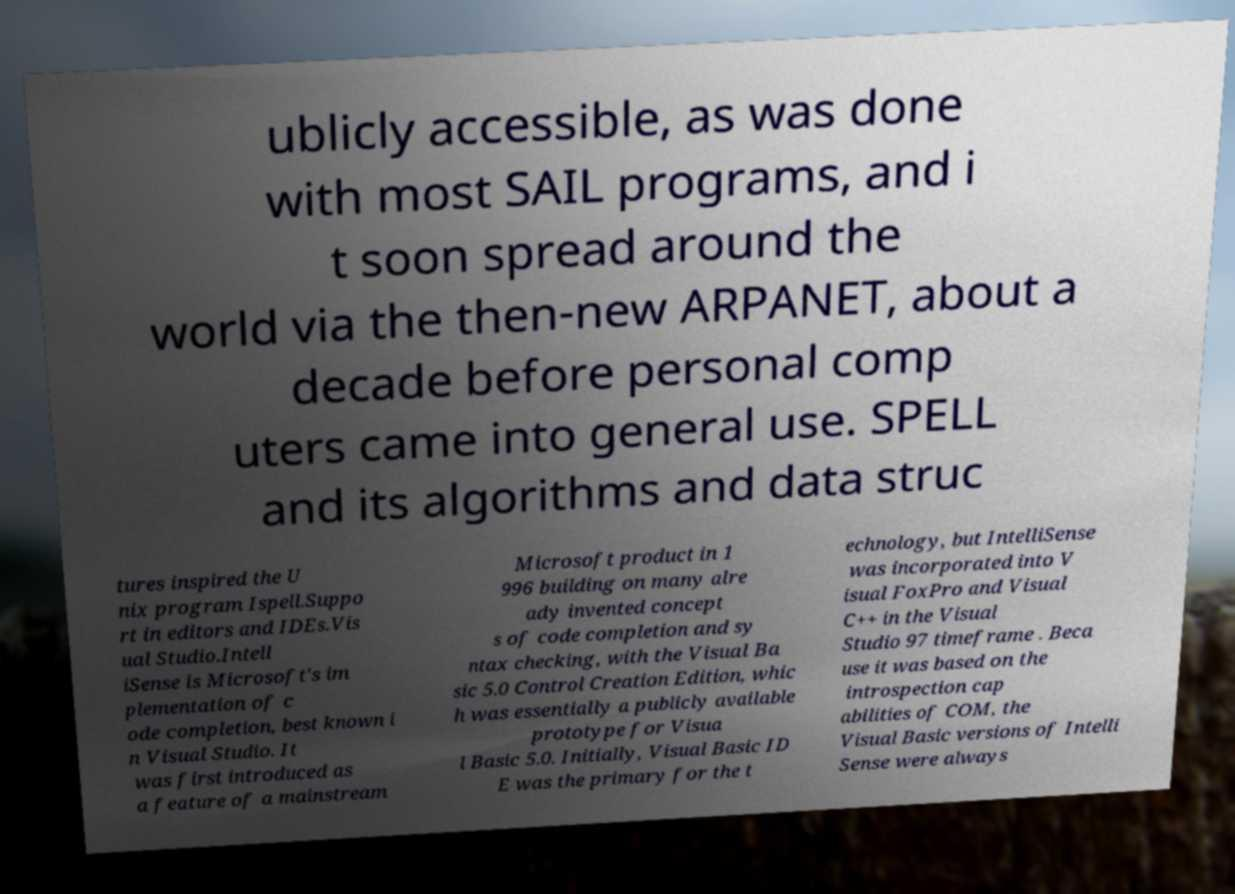There's text embedded in this image that I need extracted. Can you transcribe it verbatim? ublicly accessible, as was done with most SAIL programs, and i t soon spread around the world via the then-new ARPANET, about a decade before personal comp uters came into general use. SPELL and its algorithms and data struc tures inspired the U nix program Ispell.Suppo rt in editors and IDEs.Vis ual Studio.Intell iSense is Microsoft's im plementation of c ode completion, best known i n Visual Studio. It was first introduced as a feature of a mainstream Microsoft product in 1 996 building on many alre ady invented concept s of code completion and sy ntax checking, with the Visual Ba sic 5.0 Control Creation Edition, whic h was essentially a publicly available prototype for Visua l Basic 5.0. Initially, Visual Basic ID E was the primary for the t echnology, but IntelliSense was incorporated into V isual FoxPro and Visual C++ in the Visual Studio 97 timeframe . Beca use it was based on the introspection cap abilities of COM, the Visual Basic versions of Intelli Sense were always 